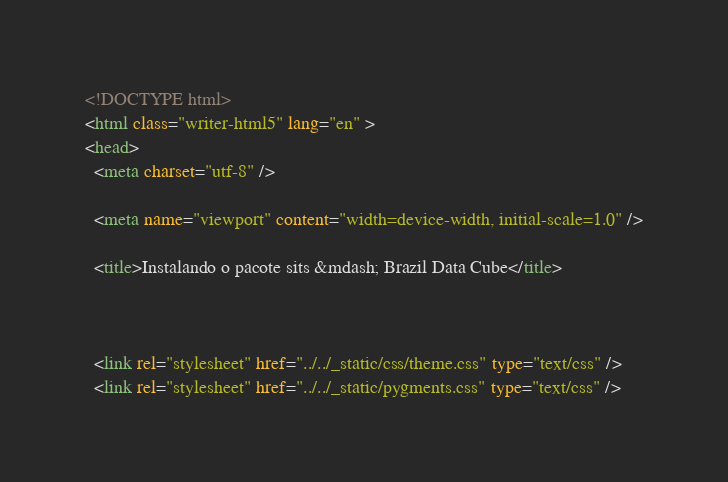<code> <loc_0><loc_0><loc_500><loc_500><_HTML_>

<!DOCTYPE html>
<html class="writer-html5" lang="en" >
<head>
  <meta charset="utf-8" />
  
  <meta name="viewport" content="width=device-width, initial-scale=1.0" />
  
  <title>Instalando o pacote sits &mdash; Brazil Data Cube</title>
  

  
  <link rel="stylesheet" href="../../_static/css/theme.css" type="text/css" />
  <link rel="stylesheet" href="../../_static/pygments.css" type="text/css" /></code> 